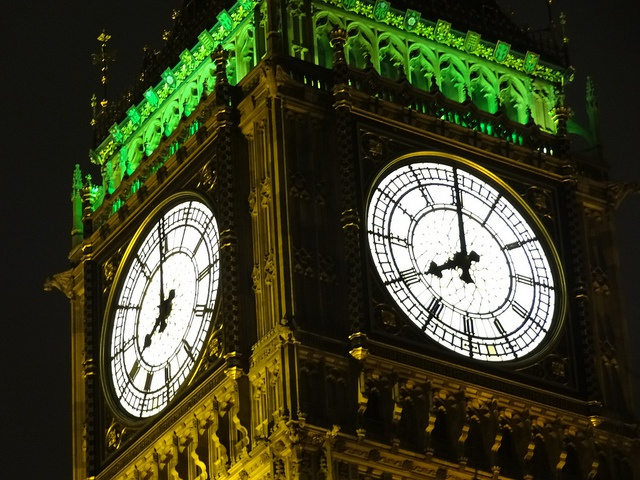Describe the objects in this image and their specific colors. I can see clock in black, white, darkgray, and gray tones and clock in black, white, darkgray, and gray tones in this image. 